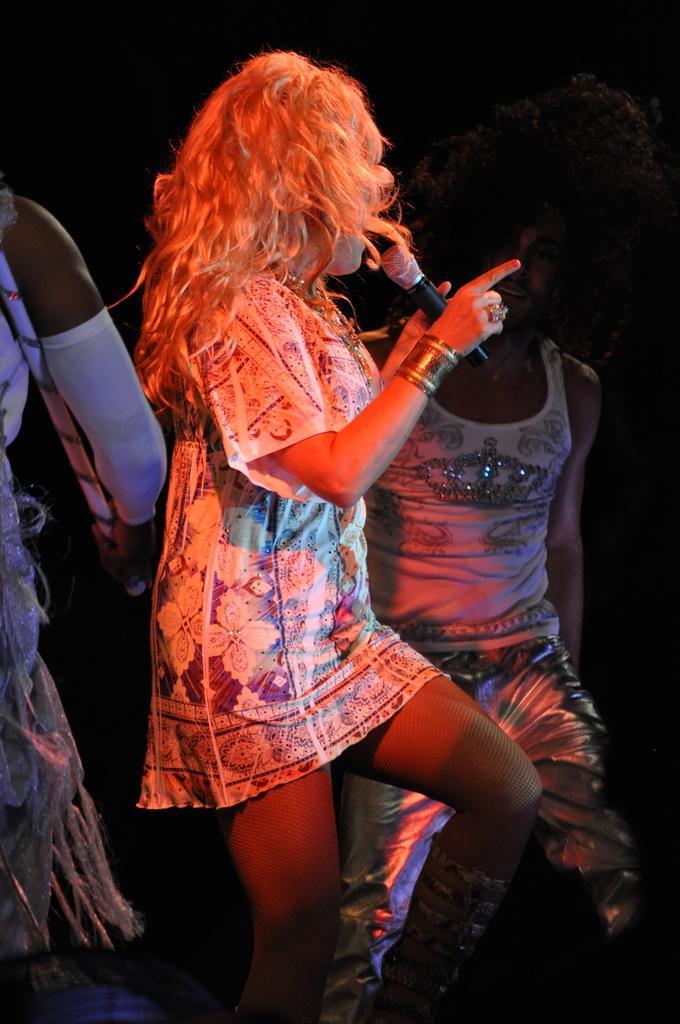Could you give a brief overview of what you see in this image? In this image, there are a few people. Among them, we can see a person holding a microphone. We can also see the dark background. We can also see an object at the bottom left. 